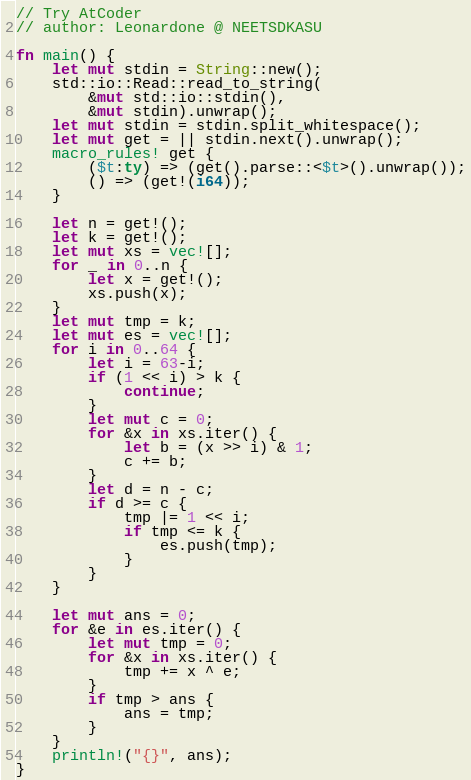<code> <loc_0><loc_0><loc_500><loc_500><_Rust_>// Try AtCoder
// author: Leonardone @ NEETSDKASU

fn main() {
	let mut stdin = String::new();
    std::io::Read::read_to_string(
    	&mut std::io::stdin(),
        &mut stdin).unwrap();
	let mut stdin = stdin.split_whitespace();
    let mut get = || stdin.next().unwrap();
    macro_rules! get {
    	($t:ty) => (get().parse::<$t>().unwrap());
        () => (get!(i64));
    }
    
    let n = get!();
    let k = get!();
    let mut xs = vec![];
    for _ in 0..n {
    	let x = get!();
        xs.push(x);
    }
    let mut tmp = k;
    let mut es = vec![];
    for i in 0..64 {
    	let i = 63-i;
    	if (1 << i) > k {
        	continue;
        }
    	let mut c = 0;
    	for &x in xs.iter() {
        	let b = (x >> i) & 1;
            c += b;
        }
        let d = n - c;
        if d >= c {
        	tmp |= 1 << i;
            if tmp <= k {
            	es.push(tmp);
            }
        }
    }

    let mut ans = 0;
    for &e in es.iter() {
	    let mut tmp = 0;
    	for &x in xs.iter() {
	    	tmp += x ^ e;
    	}
    	if tmp > ans {
	    	ans = tmp;
		}
	}
    println!("{}", ans);
}</code> 